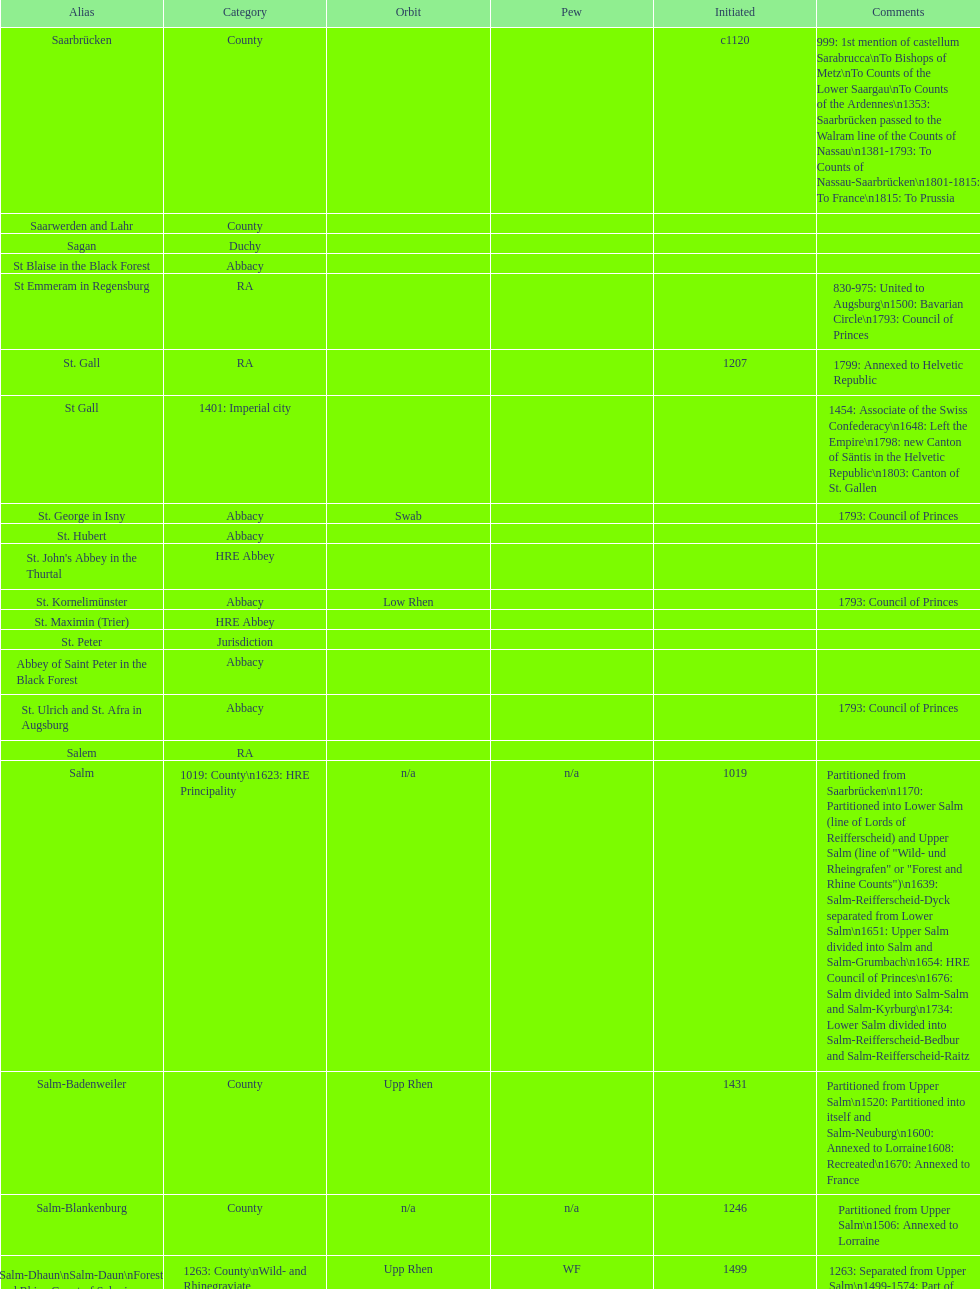What is the state above "sagan"? Saarwerden and Lahr. 